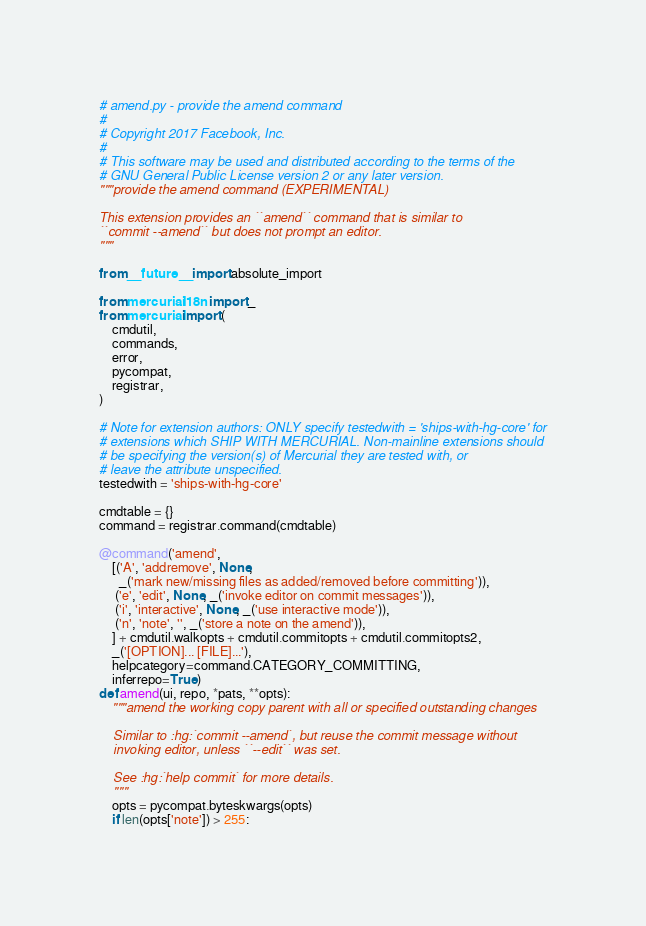Convert code to text. <code><loc_0><loc_0><loc_500><loc_500><_Python_># amend.py - provide the amend command
#
# Copyright 2017 Facebook, Inc.
#
# This software may be used and distributed according to the terms of the
# GNU General Public License version 2 or any later version.
"""provide the amend command (EXPERIMENTAL)

This extension provides an ``amend`` command that is similar to
``commit --amend`` but does not prompt an editor.
"""

from __future__ import absolute_import

from mercurial.i18n import _
from mercurial import (
    cmdutil,
    commands,
    error,
    pycompat,
    registrar,
)

# Note for extension authors: ONLY specify testedwith = 'ships-with-hg-core' for
# extensions which SHIP WITH MERCURIAL. Non-mainline extensions should
# be specifying the version(s) of Mercurial they are tested with, or
# leave the attribute unspecified.
testedwith = 'ships-with-hg-core'

cmdtable = {}
command = registrar.command(cmdtable)

@command('amend',
    [('A', 'addremove', None,
      _('mark new/missing files as added/removed before committing')),
     ('e', 'edit', None, _('invoke editor on commit messages')),
     ('i', 'interactive', None, _('use interactive mode')),
     ('n', 'note', '', _('store a note on the amend')),
    ] + cmdutil.walkopts + cmdutil.commitopts + cmdutil.commitopts2,
    _('[OPTION]... [FILE]...'),
    helpcategory=command.CATEGORY_COMMITTING,
    inferrepo=True)
def amend(ui, repo, *pats, **opts):
    """amend the working copy parent with all or specified outstanding changes

    Similar to :hg:`commit --amend`, but reuse the commit message without
    invoking editor, unless ``--edit`` was set.

    See :hg:`help commit` for more details.
    """
    opts = pycompat.byteskwargs(opts)
    if len(opts['note']) > 255:</code> 